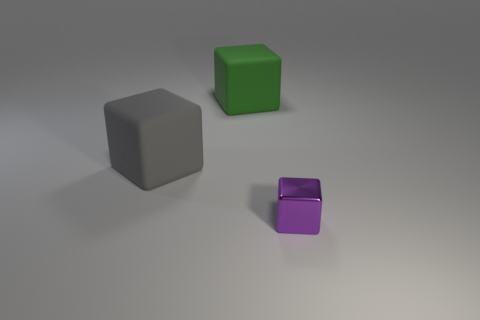Add 3 cylinders. How many objects exist? 6 Add 1 gray matte cubes. How many gray matte cubes are left? 2 Add 3 large blocks. How many large blocks exist? 5 Subtract 0 brown cylinders. How many objects are left? 3 Subtract all purple objects. Subtract all small purple metallic objects. How many objects are left? 1 